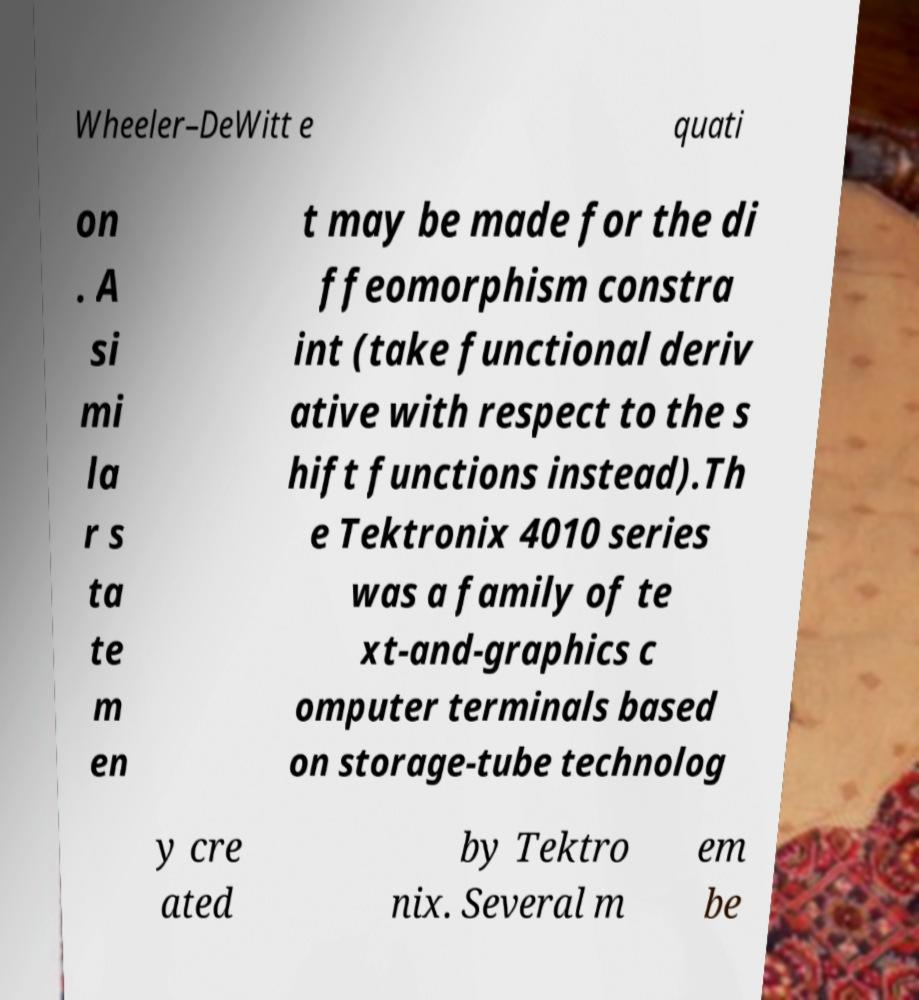Please identify and transcribe the text found in this image. Wheeler–DeWitt e quati on . A si mi la r s ta te m en t may be made for the di ffeomorphism constra int (take functional deriv ative with respect to the s hift functions instead).Th e Tektronix 4010 series was a family of te xt-and-graphics c omputer terminals based on storage-tube technolog y cre ated by Tektro nix. Several m em be 